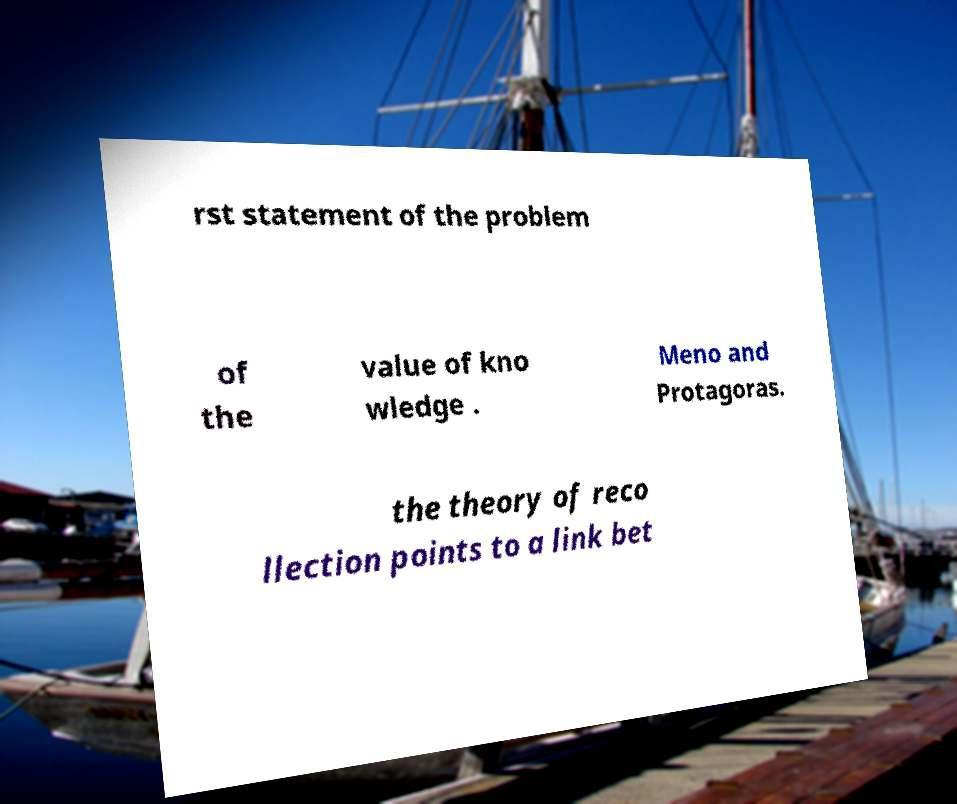Please read and relay the text visible in this image. What does it say? rst statement of the problem of the value of kno wledge . Meno and Protagoras. the theory of reco llection points to a link bet 